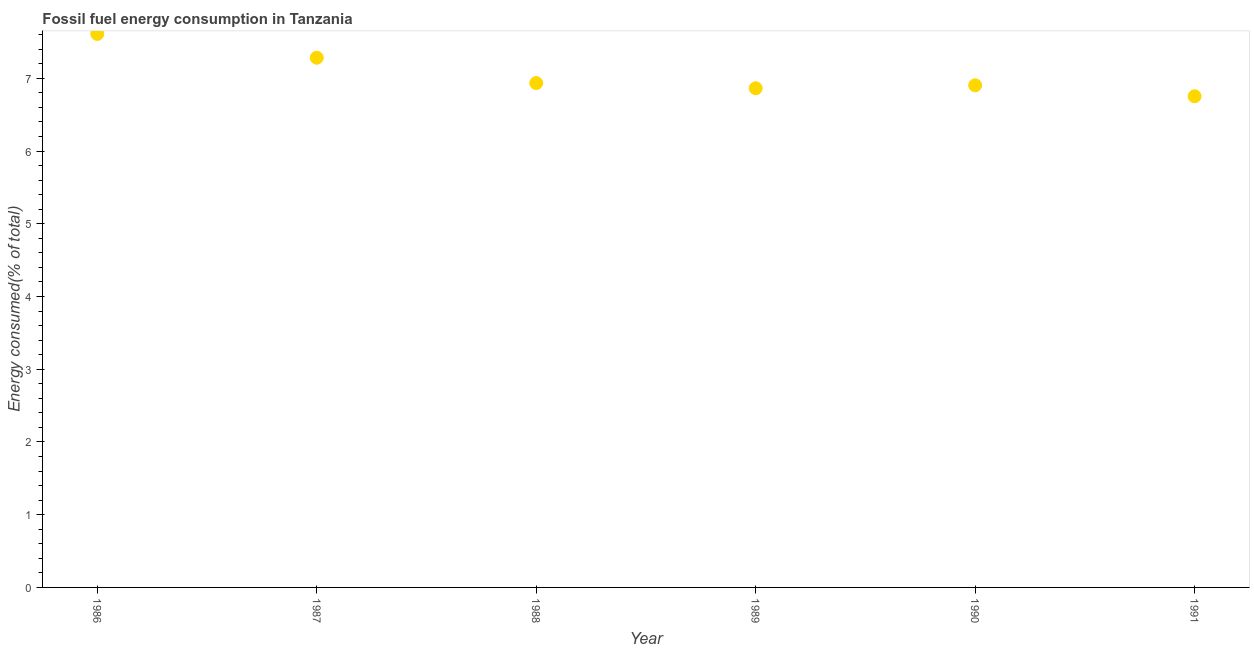What is the fossil fuel energy consumption in 1990?
Keep it short and to the point. 6.9. Across all years, what is the maximum fossil fuel energy consumption?
Your answer should be very brief. 7.61. Across all years, what is the minimum fossil fuel energy consumption?
Provide a succinct answer. 6.75. In which year was the fossil fuel energy consumption minimum?
Provide a short and direct response. 1991. What is the sum of the fossil fuel energy consumption?
Give a very brief answer. 42.35. What is the difference between the fossil fuel energy consumption in 1988 and 1990?
Offer a very short reply. 0.03. What is the average fossil fuel energy consumption per year?
Give a very brief answer. 7.06. What is the median fossil fuel energy consumption?
Make the answer very short. 6.92. What is the ratio of the fossil fuel energy consumption in 1988 to that in 1990?
Ensure brevity in your answer.  1. Is the fossil fuel energy consumption in 1987 less than that in 1988?
Make the answer very short. No. Is the difference between the fossil fuel energy consumption in 1990 and 1991 greater than the difference between any two years?
Ensure brevity in your answer.  No. What is the difference between the highest and the second highest fossil fuel energy consumption?
Ensure brevity in your answer.  0.33. What is the difference between the highest and the lowest fossil fuel energy consumption?
Make the answer very short. 0.86. In how many years, is the fossil fuel energy consumption greater than the average fossil fuel energy consumption taken over all years?
Offer a very short reply. 2. How many dotlines are there?
Provide a short and direct response. 1. How many years are there in the graph?
Make the answer very short. 6. What is the difference between two consecutive major ticks on the Y-axis?
Make the answer very short. 1. Does the graph contain any zero values?
Offer a terse response. No. Does the graph contain grids?
Provide a succinct answer. No. What is the title of the graph?
Offer a very short reply. Fossil fuel energy consumption in Tanzania. What is the label or title of the X-axis?
Provide a short and direct response. Year. What is the label or title of the Y-axis?
Your answer should be very brief. Energy consumed(% of total). What is the Energy consumed(% of total) in 1986?
Provide a succinct answer. 7.61. What is the Energy consumed(% of total) in 1987?
Your answer should be compact. 7.28. What is the Energy consumed(% of total) in 1988?
Offer a terse response. 6.93. What is the Energy consumed(% of total) in 1989?
Your response must be concise. 6.86. What is the Energy consumed(% of total) in 1990?
Offer a terse response. 6.9. What is the Energy consumed(% of total) in 1991?
Ensure brevity in your answer.  6.75. What is the difference between the Energy consumed(% of total) in 1986 and 1987?
Provide a short and direct response. 0.33. What is the difference between the Energy consumed(% of total) in 1986 and 1988?
Provide a succinct answer. 0.68. What is the difference between the Energy consumed(% of total) in 1986 and 1989?
Make the answer very short. 0.75. What is the difference between the Energy consumed(% of total) in 1986 and 1990?
Offer a terse response. 0.71. What is the difference between the Energy consumed(% of total) in 1986 and 1991?
Your answer should be compact. 0.86. What is the difference between the Energy consumed(% of total) in 1987 and 1988?
Your answer should be compact. 0.35. What is the difference between the Energy consumed(% of total) in 1987 and 1989?
Make the answer very short. 0.42. What is the difference between the Energy consumed(% of total) in 1987 and 1990?
Your answer should be very brief. 0.38. What is the difference between the Energy consumed(% of total) in 1987 and 1991?
Give a very brief answer. 0.53. What is the difference between the Energy consumed(% of total) in 1988 and 1989?
Your response must be concise. 0.07. What is the difference between the Energy consumed(% of total) in 1988 and 1990?
Your answer should be compact. 0.03. What is the difference between the Energy consumed(% of total) in 1988 and 1991?
Your answer should be very brief. 0.18. What is the difference between the Energy consumed(% of total) in 1989 and 1990?
Your answer should be compact. -0.04. What is the difference between the Energy consumed(% of total) in 1989 and 1991?
Your response must be concise. 0.11. What is the difference between the Energy consumed(% of total) in 1990 and 1991?
Offer a very short reply. 0.15. What is the ratio of the Energy consumed(% of total) in 1986 to that in 1987?
Give a very brief answer. 1.04. What is the ratio of the Energy consumed(% of total) in 1986 to that in 1988?
Ensure brevity in your answer.  1.1. What is the ratio of the Energy consumed(% of total) in 1986 to that in 1989?
Keep it short and to the point. 1.11. What is the ratio of the Energy consumed(% of total) in 1986 to that in 1990?
Offer a terse response. 1.1. What is the ratio of the Energy consumed(% of total) in 1986 to that in 1991?
Offer a terse response. 1.13. What is the ratio of the Energy consumed(% of total) in 1987 to that in 1988?
Offer a terse response. 1.05. What is the ratio of the Energy consumed(% of total) in 1987 to that in 1989?
Give a very brief answer. 1.06. What is the ratio of the Energy consumed(% of total) in 1987 to that in 1990?
Your answer should be compact. 1.05. What is the ratio of the Energy consumed(% of total) in 1987 to that in 1991?
Offer a very short reply. 1.08. What is the ratio of the Energy consumed(% of total) in 1988 to that in 1990?
Your response must be concise. 1. What is the ratio of the Energy consumed(% of total) in 1989 to that in 1990?
Your answer should be compact. 0.99. What is the ratio of the Energy consumed(% of total) in 1989 to that in 1991?
Make the answer very short. 1.02. 